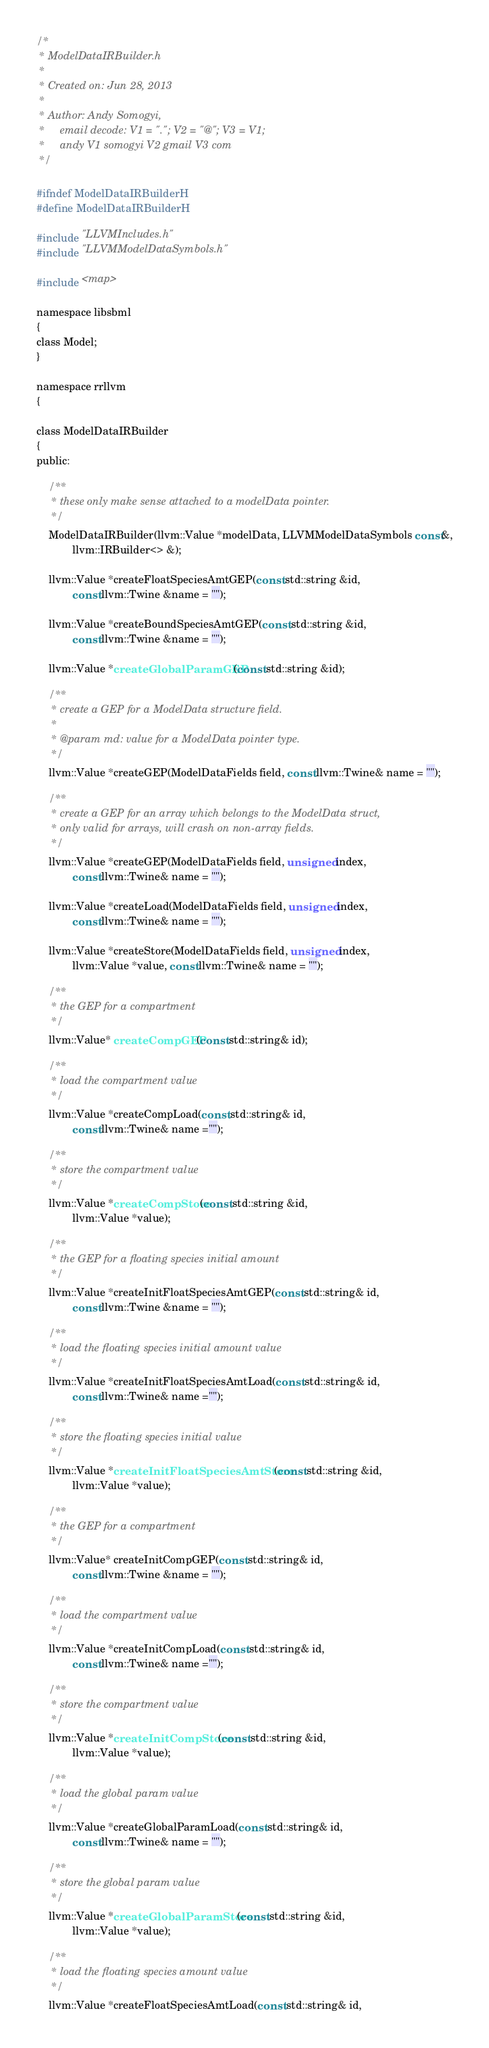Convert code to text. <code><loc_0><loc_0><loc_500><loc_500><_C_>/*
 * ModelDataIRBuilder.h
 *
 * Created on: Jun 28, 2013
 *
 * Author: Andy Somogyi,
 *     email decode: V1 = "."; V2 = "@"; V3 = V1;
 *     andy V1 somogyi V2 gmail V3 com
 */

#ifndef ModelDataIRBuilderH
#define ModelDataIRBuilderH

#include "LLVMIncludes.h"
#include "LLVMModelDataSymbols.h"

#include <map>

namespace libsbml
{
class Model;
}

namespace rrllvm
{

class ModelDataIRBuilder
{
public:

    /**
     * these only make sense attached to a modelData pointer.
     */
    ModelDataIRBuilder(llvm::Value *modelData, LLVMModelDataSymbols const&,
            llvm::IRBuilder<> &);

    llvm::Value *createFloatSpeciesAmtGEP(const std::string &id,
            const llvm::Twine &name = "");

    llvm::Value *createBoundSpeciesAmtGEP(const std::string &id,
            const llvm::Twine &name = "");

    llvm::Value *createGlobalParamGEP(const std::string &id);

    /**
     * create a GEP for a ModelData structure field.
     *
     * @param md: value for a ModelData pointer type.
     */
    llvm::Value *createGEP(ModelDataFields field, const llvm::Twine& name = "");

    /**
     * create a GEP for an array which belongs to the ModelData struct,
     * only valid for arrays, will crash on non-array fields.
     */
    llvm::Value *createGEP(ModelDataFields field, unsigned index,
            const llvm::Twine& name = "");

    llvm::Value *createLoad(ModelDataFields field, unsigned index,
            const llvm::Twine& name = "");

    llvm::Value *createStore(ModelDataFields field, unsigned index,
            llvm::Value *value, const llvm::Twine& name = "");

    /**
     * the GEP for a compartment
     */
    llvm::Value* createCompGEP(const std::string& id);

    /**
     * load the compartment value
     */
    llvm::Value *createCompLoad(const std::string& id,
            const llvm::Twine& name ="");

    /**
     * store the compartment value
     */
    llvm::Value *createCompStore(const std::string &id,
            llvm::Value *value);

    /**
     * the GEP for a floating species initial amount
     */
    llvm::Value *createInitFloatSpeciesAmtGEP(const std::string& id,
            const llvm::Twine &name = "");

    /**
     * load the floating species initial amount value
     */
    llvm::Value *createInitFloatSpeciesAmtLoad(const std::string& id,
            const llvm::Twine& name ="");

    /**
     * store the floating species initial value
     */
    llvm::Value *createInitFloatSpeciesAmtStore(const std::string &id,
            llvm::Value *value);

    /**
     * the GEP for a compartment
     */
    llvm::Value* createInitCompGEP(const std::string& id,
            const llvm::Twine &name = "");

    /**
     * load the compartment value
     */
    llvm::Value *createInitCompLoad(const std::string& id,
            const llvm::Twine& name ="");

    /**
     * store the compartment value
     */
    llvm::Value *createInitCompStore(const std::string &id,
            llvm::Value *value);

    /**
     * load the global param value
     */
    llvm::Value *createGlobalParamLoad(const std::string& id,
            const llvm::Twine& name = "");

    /**
     * store the global param value
     */
    llvm::Value *createGlobalParamStore(const std::string &id,
            llvm::Value *value);

    /**
     * load the floating species amount value
     */
    llvm::Value *createFloatSpeciesAmtLoad(const std::string& id,</code> 